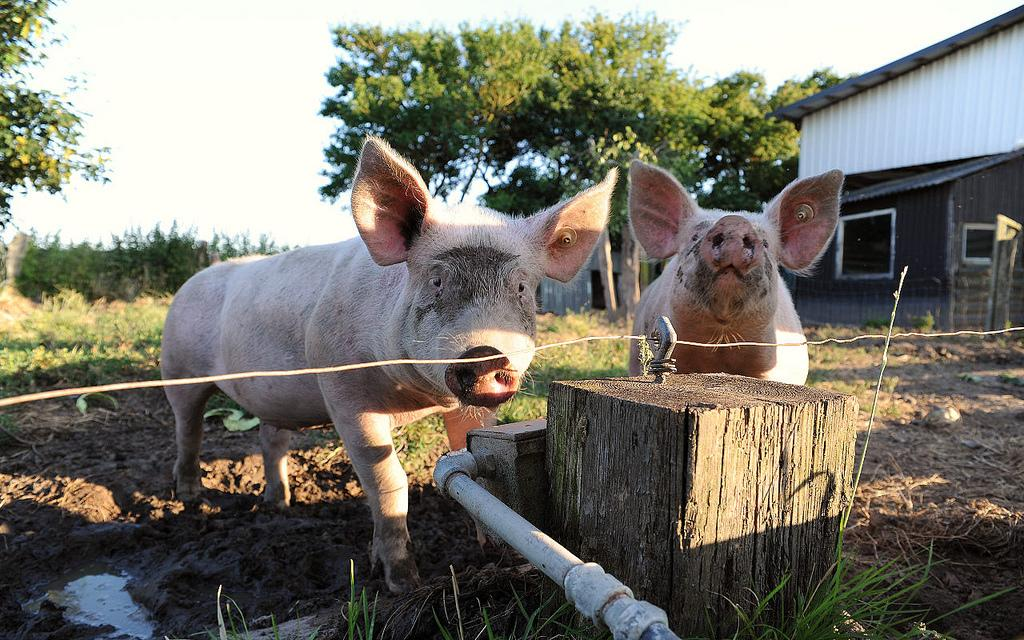What animals are present in the image? There are pigs in the image. What type of structure can be seen in the image? There is a water pipe and a wooden board in the image. What can be seen in the background of the image? There are trees, a shed, and the sky visible in the background of the image. What type of design is featured on the baseball in the image? There is no baseball present in the image; it features pigs, a water pipe, a wooden board, trees, a shed, and the sky. 